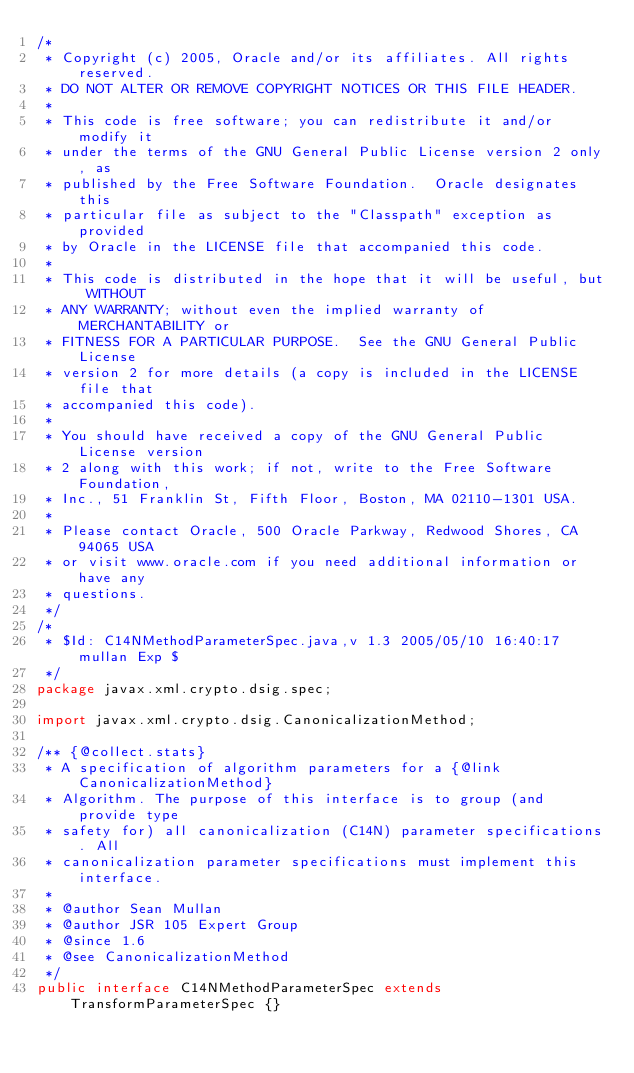Convert code to text. <code><loc_0><loc_0><loc_500><loc_500><_Java_>/*
 * Copyright (c) 2005, Oracle and/or its affiliates. All rights reserved.
 * DO NOT ALTER OR REMOVE COPYRIGHT NOTICES OR THIS FILE HEADER.
 *
 * This code is free software; you can redistribute it and/or modify it
 * under the terms of the GNU General Public License version 2 only, as
 * published by the Free Software Foundation.  Oracle designates this
 * particular file as subject to the "Classpath" exception as provided
 * by Oracle in the LICENSE file that accompanied this code.
 *
 * This code is distributed in the hope that it will be useful, but WITHOUT
 * ANY WARRANTY; without even the implied warranty of MERCHANTABILITY or
 * FITNESS FOR A PARTICULAR PURPOSE.  See the GNU General Public License
 * version 2 for more details (a copy is included in the LICENSE file that
 * accompanied this code).
 *
 * You should have received a copy of the GNU General Public License version
 * 2 along with this work; if not, write to the Free Software Foundation,
 * Inc., 51 Franklin St, Fifth Floor, Boston, MA 02110-1301 USA.
 *
 * Please contact Oracle, 500 Oracle Parkway, Redwood Shores, CA 94065 USA
 * or visit www.oracle.com if you need additional information or have any
 * questions.
 */
/*
 * $Id: C14NMethodParameterSpec.java,v 1.3 2005/05/10 16:40:17 mullan Exp $
 */
package javax.xml.crypto.dsig.spec;

import javax.xml.crypto.dsig.CanonicalizationMethod;

/** {@collect.stats}
 * A specification of algorithm parameters for a {@link CanonicalizationMethod}
 * Algorithm. The purpose of this interface is to group (and provide type
 * safety for) all canonicalization (C14N) parameter specifications. All
 * canonicalization parameter specifications must implement this interface.
 *
 * @author Sean Mullan
 * @author JSR 105 Expert Group
 * @since 1.6
 * @see CanonicalizationMethod
 */
public interface C14NMethodParameterSpec extends TransformParameterSpec {}
</code> 